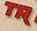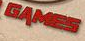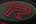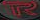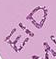Transcribe the words shown in these images in order, separated by a semicolon. TR; GAMES; R; R; EID 